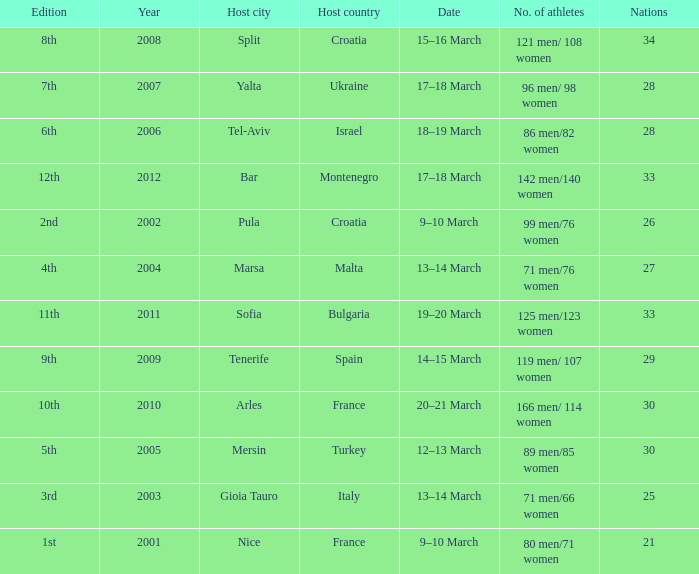What was the host city of the 8th edition in the the host country of Croatia? Split. 